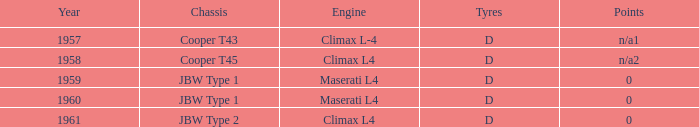Which firm constructed the chassis for a year following 1959 and a peak l4 motor? JBW Type 2. 